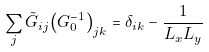<formula> <loc_0><loc_0><loc_500><loc_500>\sum _ { j } { \tilde { G } } _ { i j } { \left ( { G } _ { 0 } ^ { - 1 } \right ) } _ { j k } = \delta _ { i k } - \frac { 1 } { L _ { x } L _ { y } }</formula> 